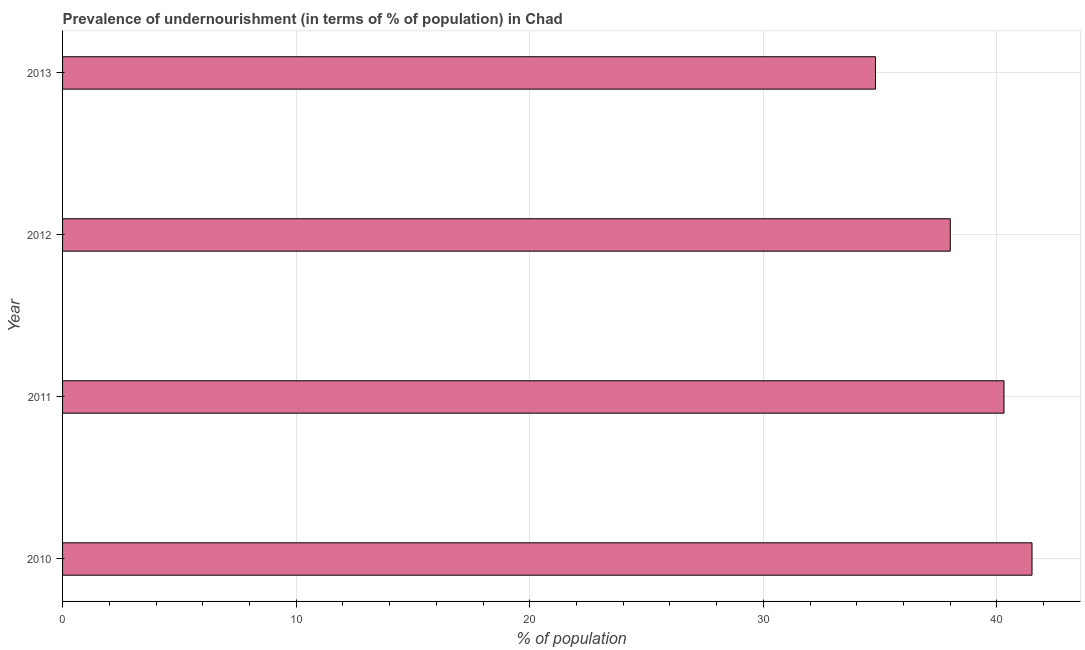Does the graph contain any zero values?
Provide a short and direct response. No. What is the title of the graph?
Your response must be concise. Prevalence of undernourishment (in terms of % of population) in Chad. What is the label or title of the X-axis?
Provide a succinct answer. % of population. What is the percentage of undernourished population in 2011?
Your response must be concise. 40.3. Across all years, what is the maximum percentage of undernourished population?
Provide a short and direct response. 41.5. Across all years, what is the minimum percentage of undernourished population?
Ensure brevity in your answer.  34.8. In which year was the percentage of undernourished population maximum?
Your answer should be very brief. 2010. What is the sum of the percentage of undernourished population?
Your answer should be very brief. 154.6. What is the difference between the percentage of undernourished population in 2010 and 2013?
Provide a succinct answer. 6.7. What is the average percentage of undernourished population per year?
Make the answer very short. 38.65. What is the median percentage of undernourished population?
Give a very brief answer. 39.15. In how many years, is the percentage of undernourished population greater than 8 %?
Make the answer very short. 4. Do a majority of the years between 2011 and 2013 (inclusive) have percentage of undernourished population greater than 18 %?
Ensure brevity in your answer.  Yes. What is the ratio of the percentage of undernourished population in 2011 to that in 2012?
Keep it short and to the point. 1.06. What is the difference between the highest and the second highest percentage of undernourished population?
Provide a succinct answer. 1.2. What is the difference between the highest and the lowest percentage of undernourished population?
Provide a short and direct response. 6.7. What is the difference between two consecutive major ticks on the X-axis?
Your answer should be very brief. 10. What is the % of population of 2010?
Your response must be concise. 41.5. What is the % of population of 2011?
Give a very brief answer. 40.3. What is the % of population of 2012?
Your answer should be compact. 38. What is the % of population in 2013?
Your answer should be very brief. 34.8. What is the difference between the % of population in 2010 and 2013?
Make the answer very short. 6.7. What is the difference between the % of population in 2011 and 2012?
Offer a very short reply. 2.3. What is the ratio of the % of population in 2010 to that in 2012?
Your answer should be compact. 1.09. What is the ratio of the % of population in 2010 to that in 2013?
Make the answer very short. 1.19. What is the ratio of the % of population in 2011 to that in 2012?
Your response must be concise. 1.06. What is the ratio of the % of population in 2011 to that in 2013?
Make the answer very short. 1.16. What is the ratio of the % of population in 2012 to that in 2013?
Offer a very short reply. 1.09. 